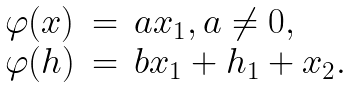<formula> <loc_0><loc_0><loc_500><loc_500>\begin{array} { l l l l } \varphi ( x ) & = & a x _ { 1 } , a \neq 0 , \\ \varphi ( h ) & = & b x _ { 1 } + h _ { 1 } + x _ { 2 } . \end{array}</formula> 